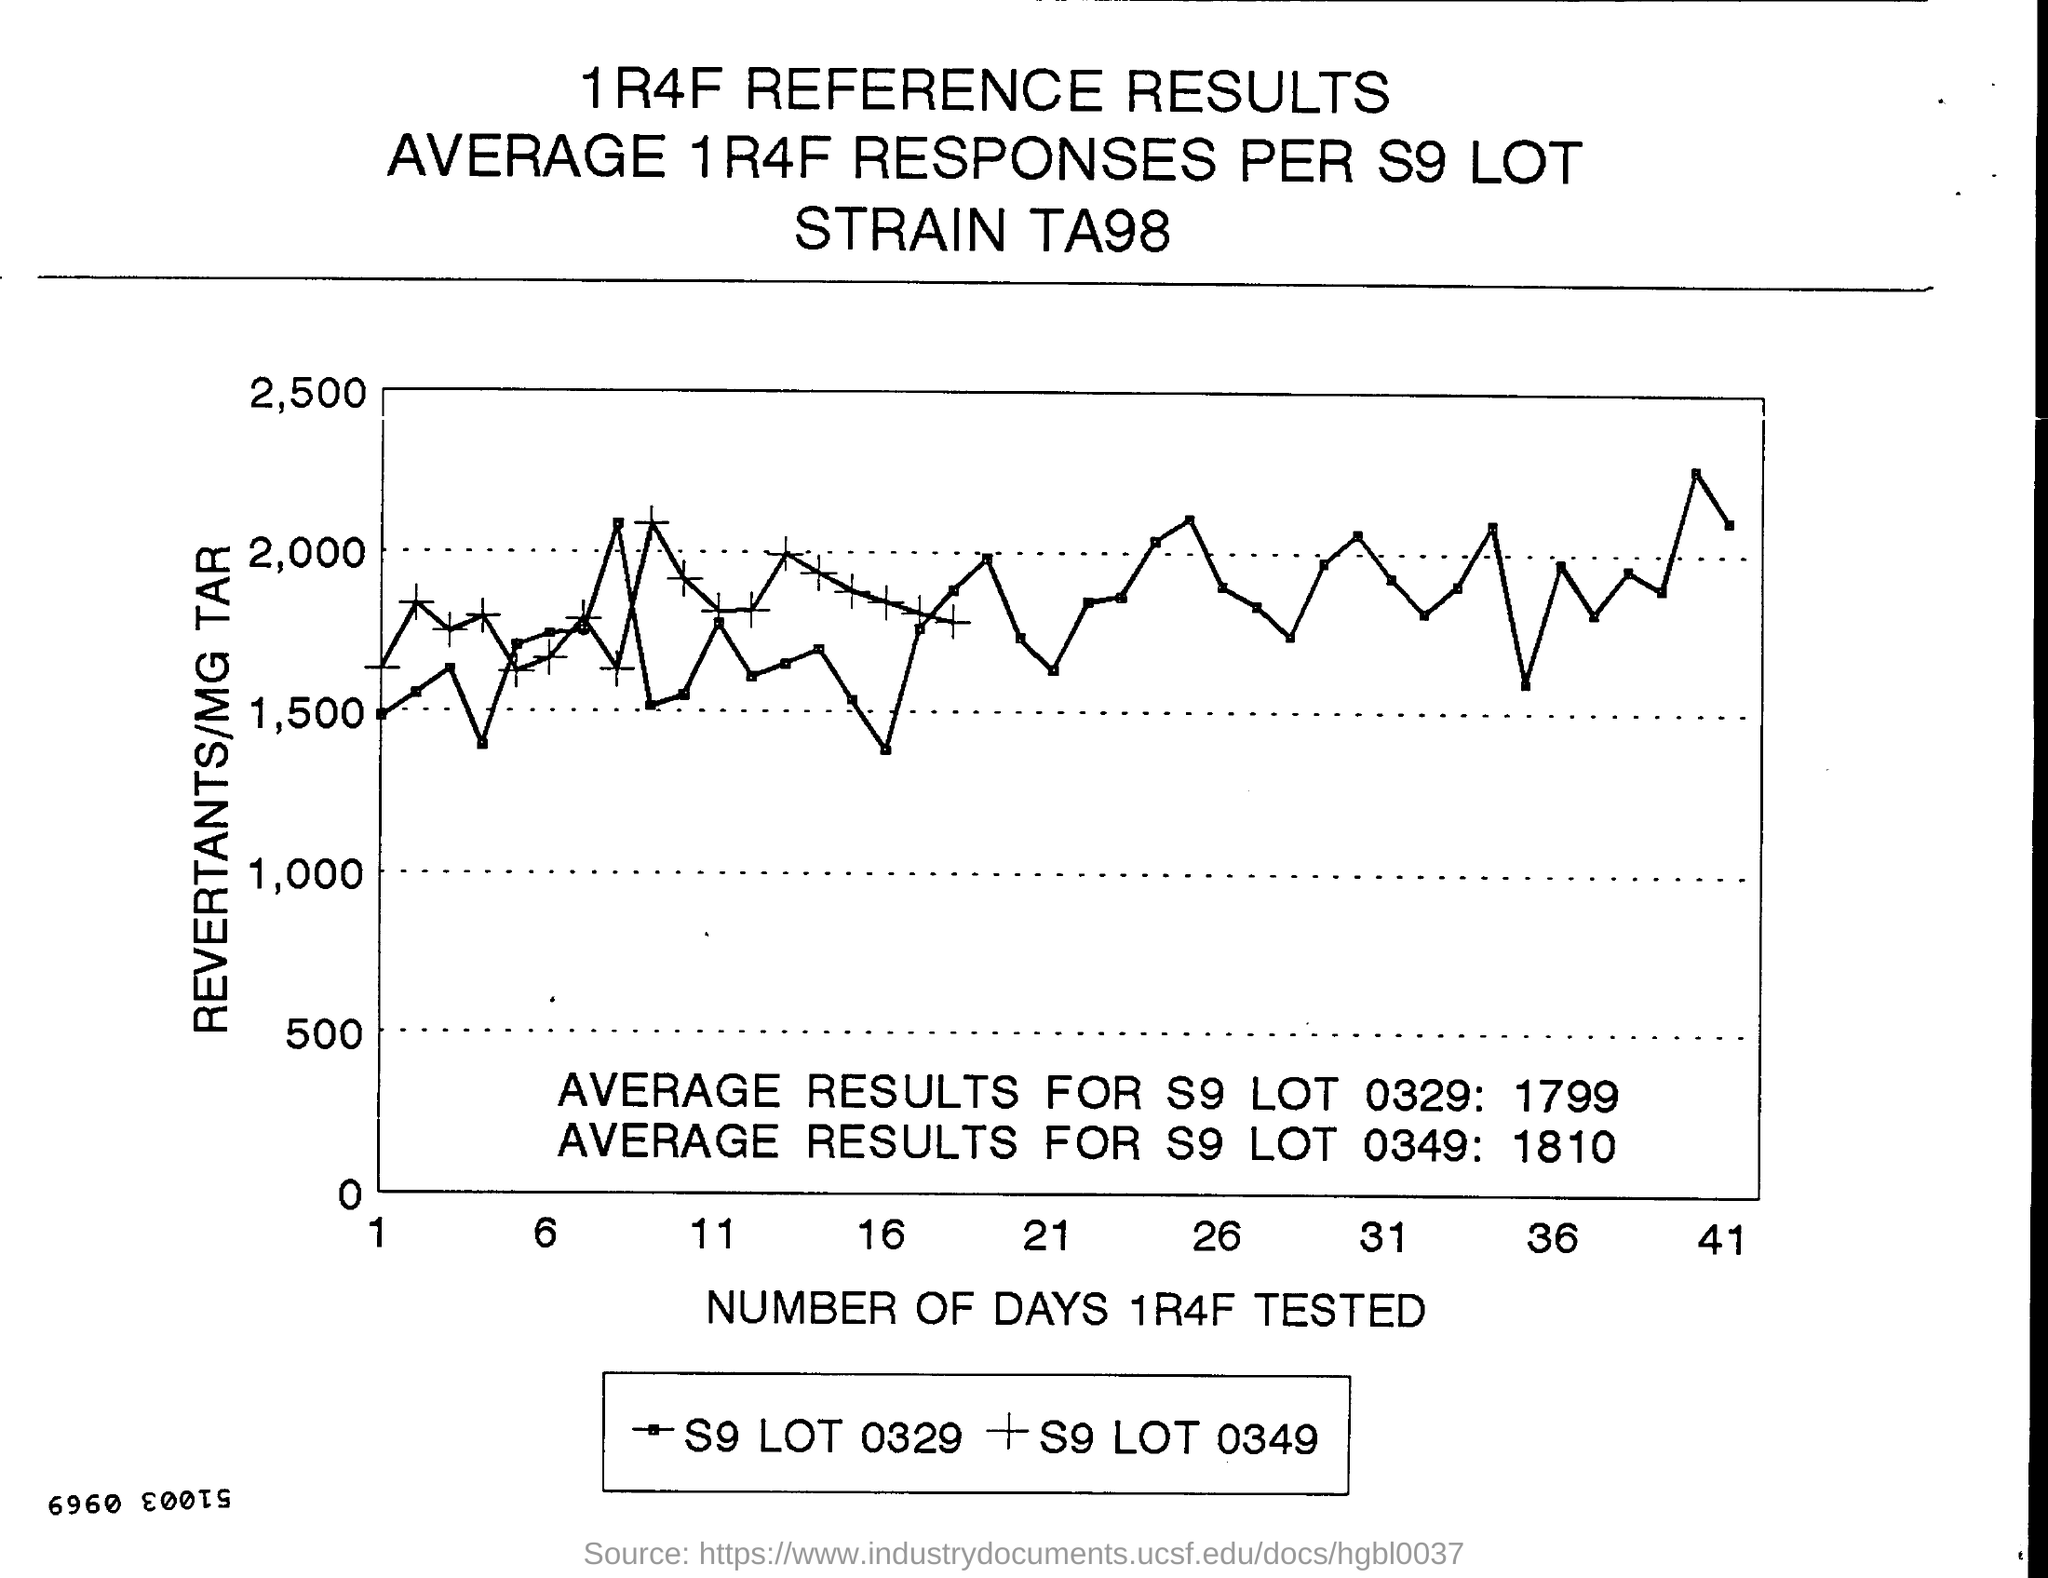List a handful of essential elements in this visual. The Y-axis in the graph represents the number of revertants per milligram of tar in the smoke condensate samples tested. The value 2000 is written in the Y axis of the graph as the second highest value. The number of days that were tested is represented along the x-axis in the graph. The highest value written in the X axis of the graph is 41. The second highest value written on the X-axis of the graph is 36. 